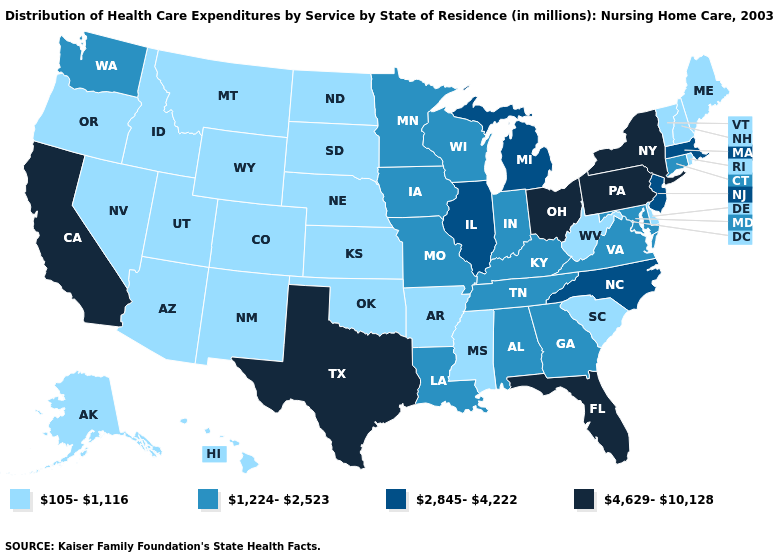What is the value of California?
Be succinct. 4,629-10,128. Does the first symbol in the legend represent the smallest category?
Quick response, please. Yes. What is the highest value in states that border Oklahoma?
Give a very brief answer. 4,629-10,128. Which states have the lowest value in the USA?
Keep it brief. Alaska, Arizona, Arkansas, Colorado, Delaware, Hawaii, Idaho, Kansas, Maine, Mississippi, Montana, Nebraska, Nevada, New Hampshire, New Mexico, North Dakota, Oklahoma, Oregon, Rhode Island, South Carolina, South Dakota, Utah, Vermont, West Virginia, Wyoming. What is the value of Minnesota?
Keep it brief. 1,224-2,523. What is the value of Massachusetts?
Answer briefly. 2,845-4,222. What is the lowest value in states that border Nevada?
Answer briefly. 105-1,116. Name the states that have a value in the range 4,629-10,128?
Write a very short answer. California, Florida, New York, Ohio, Pennsylvania, Texas. Name the states that have a value in the range 1,224-2,523?
Give a very brief answer. Alabama, Connecticut, Georgia, Indiana, Iowa, Kentucky, Louisiana, Maryland, Minnesota, Missouri, Tennessee, Virginia, Washington, Wisconsin. What is the value of Maryland?
Write a very short answer. 1,224-2,523. Name the states that have a value in the range 105-1,116?
Write a very short answer. Alaska, Arizona, Arkansas, Colorado, Delaware, Hawaii, Idaho, Kansas, Maine, Mississippi, Montana, Nebraska, Nevada, New Hampshire, New Mexico, North Dakota, Oklahoma, Oregon, Rhode Island, South Carolina, South Dakota, Utah, Vermont, West Virginia, Wyoming. What is the lowest value in the USA?
Keep it brief. 105-1,116. Which states have the lowest value in the South?
Quick response, please. Arkansas, Delaware, Mississippi, Oklahoma, South Carolina, West Virginia. What is the highest value in states that border Arizona?
Be succinct. 4,629-10,128. What is the value of Idaho?
Answer briefly. 105-1,116. 